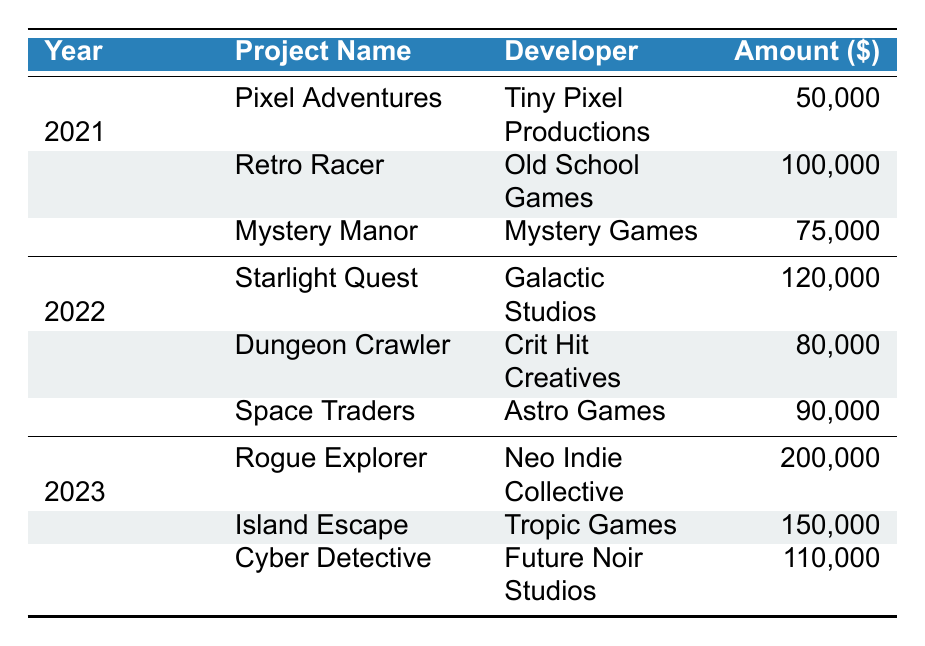What was the total amount received for projects in 2021? In 2021, the amounts received were 50000 for Pixel Adventures, 100000 for Retro Racer, and 75000 for Mystery Manor. Adding these amounts gives: 50000 + 100000 + 75000 = 225000.
Answer: 225000 How much funding did Galactic Studios receive for Starlight Quest? The table shows that Galactic Studios received 120000 for the project Starlight Quest in 2022.
Answer: 120000 Was there any project that received funding from the Epic Games Grants in 2021? The table lists projects in 2021, and only the project Mystery Manor received funding from Epic Games Grants. Therefore, the statement is yes.
Answer: Yes Which developer received the highest amount in 2023 and how much was it? The projects listed for 2023 are Rogue Explorer, Island Escape, and Cyber Detective. The amounts received are 200000, 150000, and 110000 respectively. Rogue Explorer received the highest amount, 200000.
Answer: Rogue Explorer, 200000 What is the average funding amount across all projects from the year 2022? The projects listed in 2022 received 120000 for Starlight Quest, 80000 for Dungeon Crawler, and 90000 for Space Traders. To find the average, sum these amounts: 120000 + 80000 + 90000 = 290000. Then divide by the number of projects (3): 290000 / 3 = 96666.67.
Answer: 96666.67 Did more than two projects receive funding from Kickstarter in the last three years? The table shows projects funded by Kickstarter: Pixel Adventures (2021), Starlight Quest (2022), and Rogue Explorer (2023), totaling 3 projects. Therefore, the answer is yes.
Answer: Yes What is the difference in funding amounts received by the highest and the lowest funded projects in 2021? In 2021, the highest funding amount was 100000 (Retro Racer) and the lowest was 50000 (Pixel Adventures). The difference is 100000 - 50000 = 50000.
Answer: 50000 Which funding source provided the largest total amount in 2023? The funding amounts in 2023 were 200000 (Kickstarter), 150000 (Epic Games Grants), and 110000 (Indie Fund). The largest amount is from Kickstarter, totaling 200000.
Answer: Kickstarter, 200000 